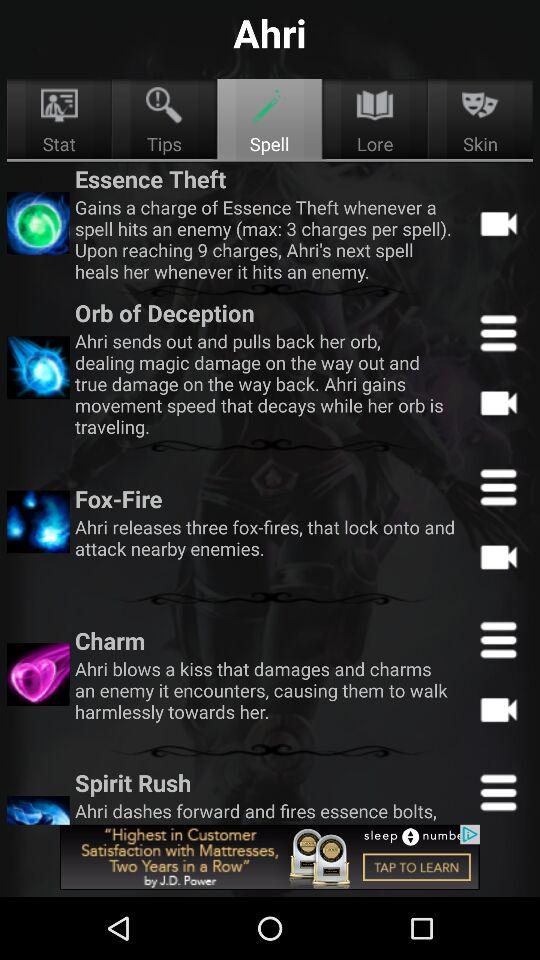Which option is selected? The selected option is "Spell". 